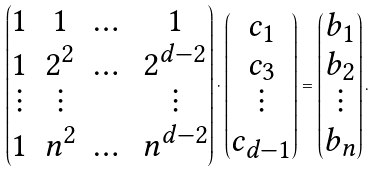Convert formula to latex. <formula><loc_0><loc_0><loc_500><loc_500>\begin{pmatrix} 1 & 1 & \dots & 1 \\ 1 & 2 ^ { 2 } & \dots & 2 ^ { d - 2 } \\ \vdots & \vdots & & \vdots \\ 1 & n ^ { 2 } & \dots & n ^ { d - 2 } \end{pmatrix} \cdot \begin{pmatrix} c _ { 1 } \\ c _ { 3 } \\ \vdots \\ c _ { d - 1 } \end{pmatrix} = \begin{pmatrix} b _ { 1 } \\ b _ { 2 } \\ \vdots \\ b _ { n } \end{pmatrix} .</formula> 